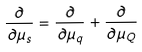<formula> <loc_0><loc_0><loc_500><loc_500>\frac { \partial } { \partial \mu _ { s } } = \frac { \partial } { \partial \mu _ { q } } + \frac { \partial } { \partial \mu _ { Q } }</formula> 